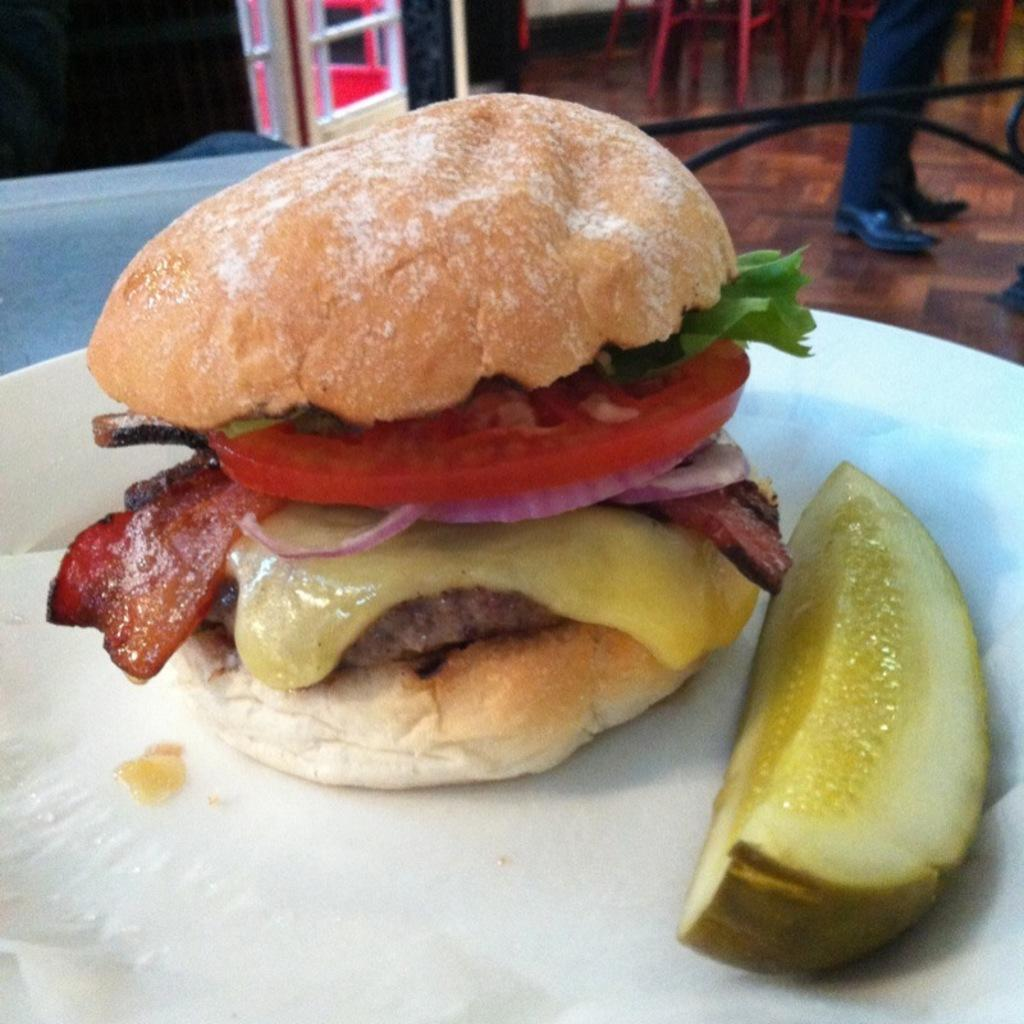What is on the plate in the image? There are food items on a plate in the image. What type of furniture can be seen in the image? There are chairs in the image. Whose legs are visible in the image? The legs of a person are visible in the image. What type of base is supporting the flower in the image? There is no flower present in the image, so there is no base supporting it. 